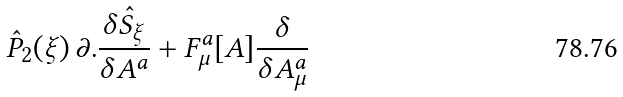Convert formula to latex. <formula><loc_0><loc_0><loc_500><loc_500>{ \hat { P } } _ { 2 } ( \xi ) \, \partial . \frac { \delta { \hat { S } } _ { \xi } } { \delta A ^ { a } } + F _ { \mu } ^ { a } [ A ] \frac { \delta } { \delta A ^ { a } _ { \mu } }</formula> 